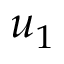<formula> <loc_0><loc_0><loc_500><loc_500>u _ { 1 }</formula> 